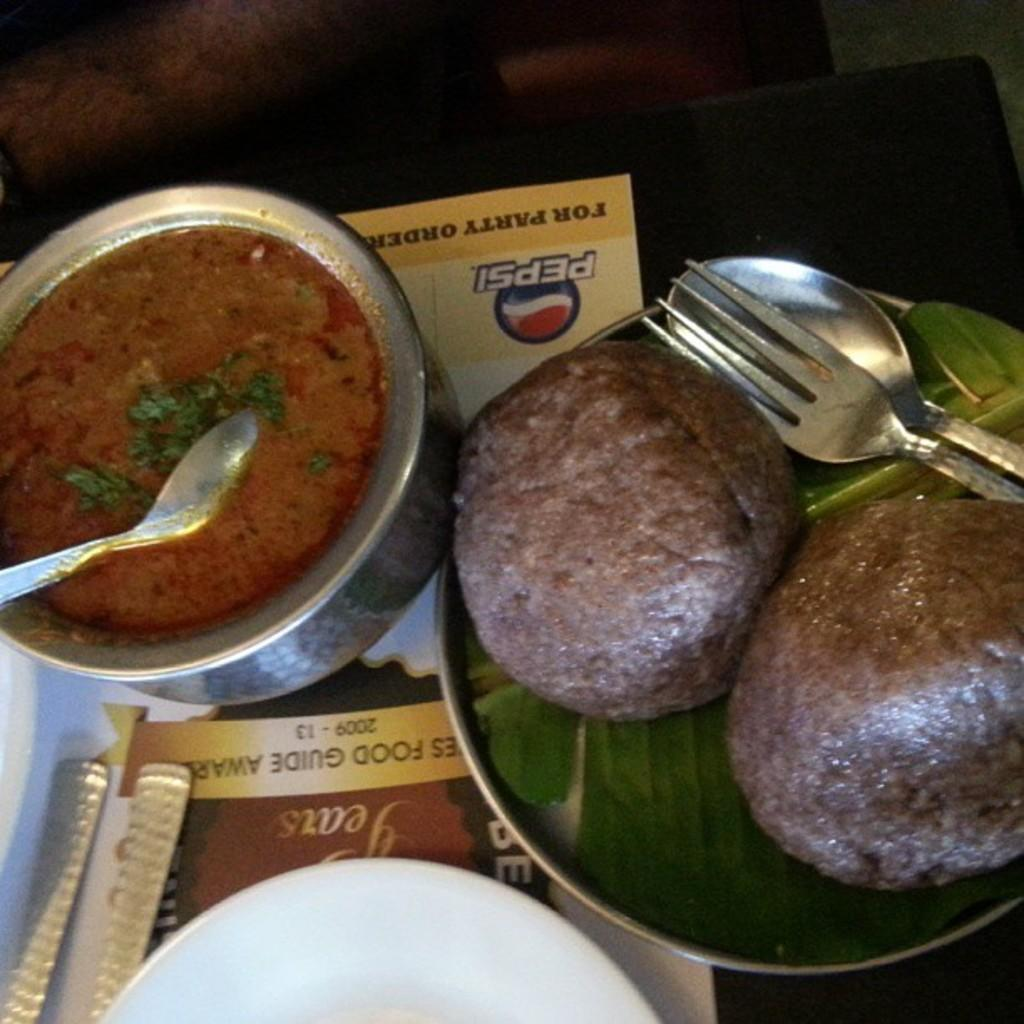What is located in the center of the image? There is a bowl and a plate in the center of the image. What is the purpose of the bowl and plate in the image? The bowl and plate contain food items. What is the belief system of the food items on the plate? The food items on the plate do not have a belief system, as they are inanimate objects. 